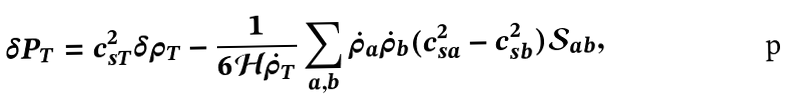Convert formula to latex. <formula><loc_0><loc_0><loc_500><loc_500>\delta P _ { T } = c ^ { 2 } _ { s T } \delta \rho _ { T } - \frac { 1 } { 6 \mathcal { H } \dot { \rho } _ { T } } \sum _ { a , b } \dot { \rho } _ { a } \dot { \rho } _ { b } ( c ^ { 2 } _ { s a } - c ^ { 2 } _ { s b } ) \mathcal { S } _ { a b } ,</formula> 